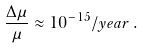Convert formula to latex. <formula><loc_0><loc_0><loc_500><loc_500>\frac { \Delta \mu } { \mu } \approx 1 0 ^ { - 1 5 } / y e a r \, .</formula> 